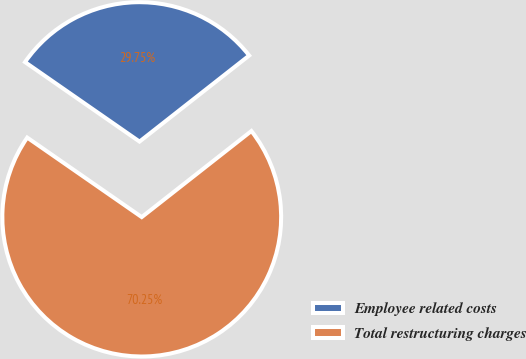Convert chart. <chart><loc_0><loc_0><loc_500><loc_500><pie_chart><fcel>Employee related costs<fcel>Total restructuring charges<nl><fcel>29.75%<fcel>70.25%<nl></chart> 